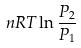<formula> <loc_0><loc_0><loc_500><loc_500>n R T \ln \frac { P _ { 2 } } { P _ { 1 } }</formula> 